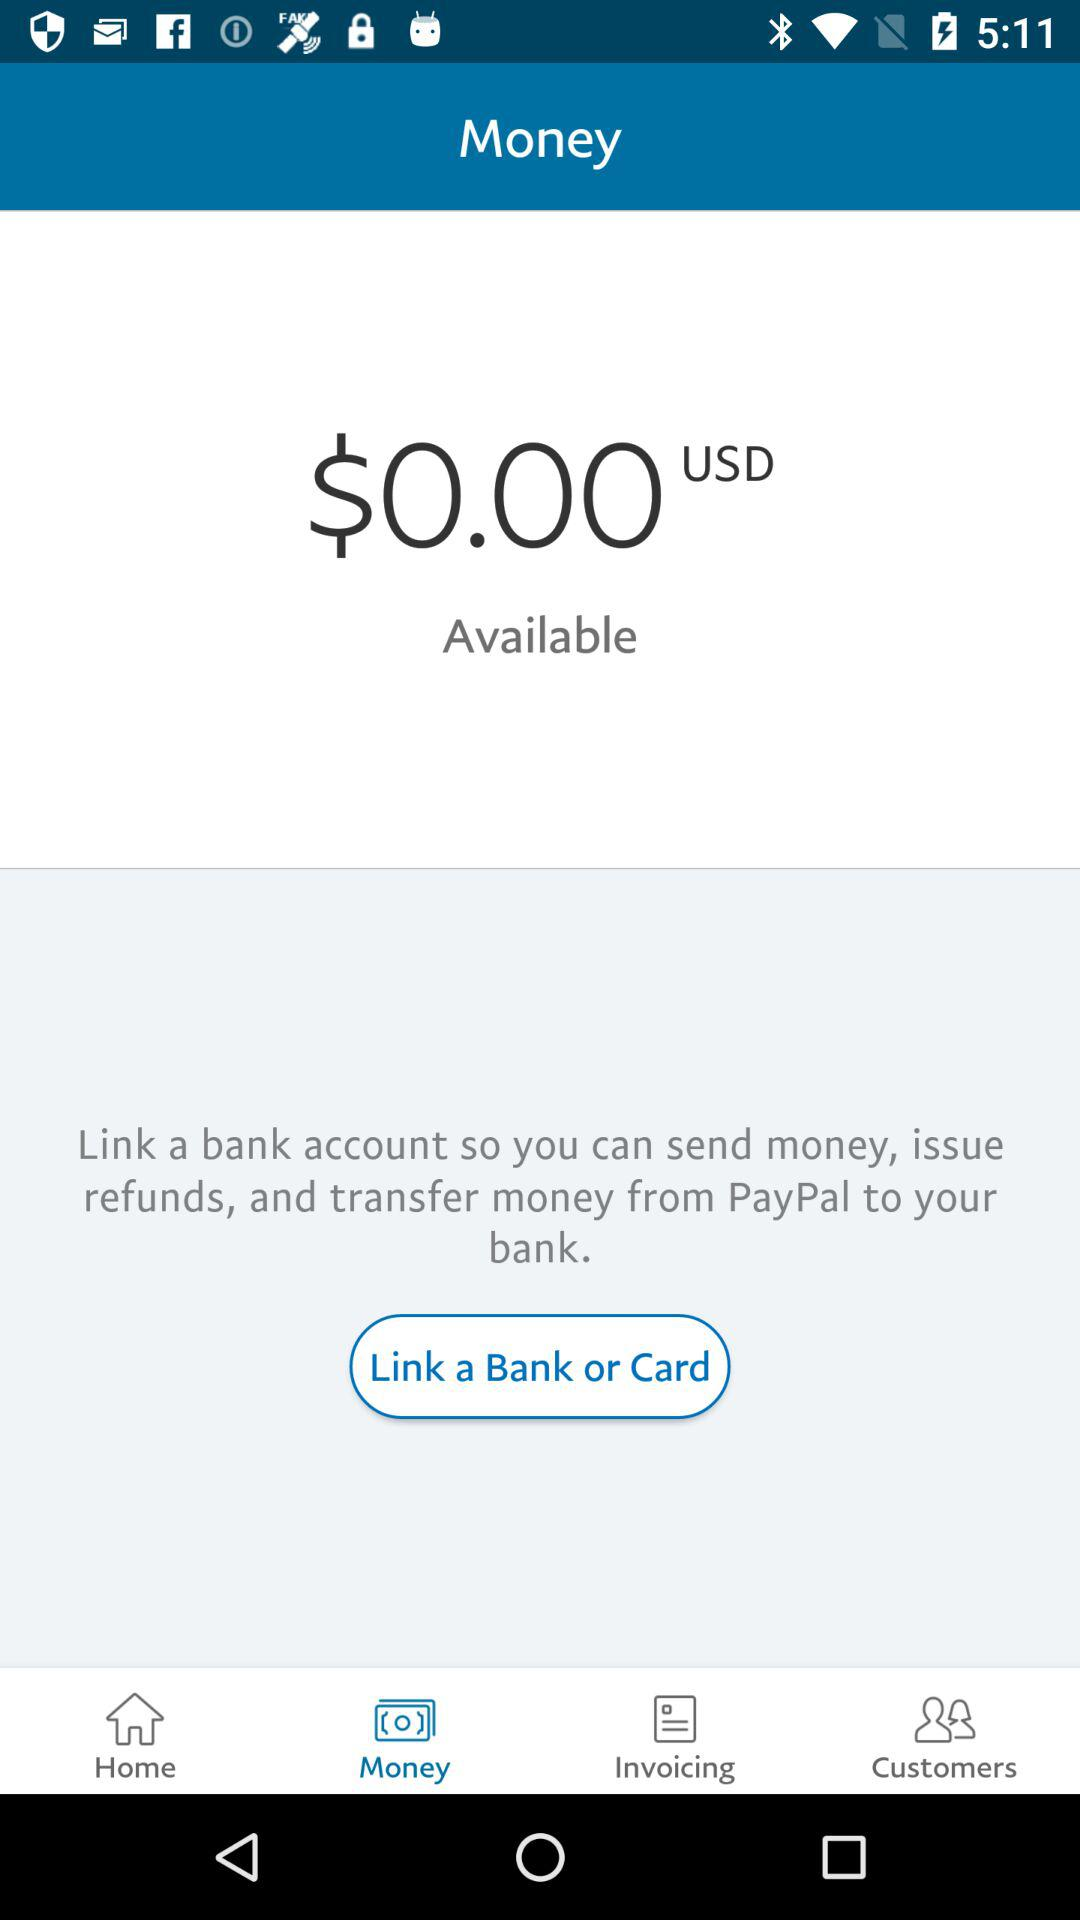What is the available amount? The available amount is $0.00. 